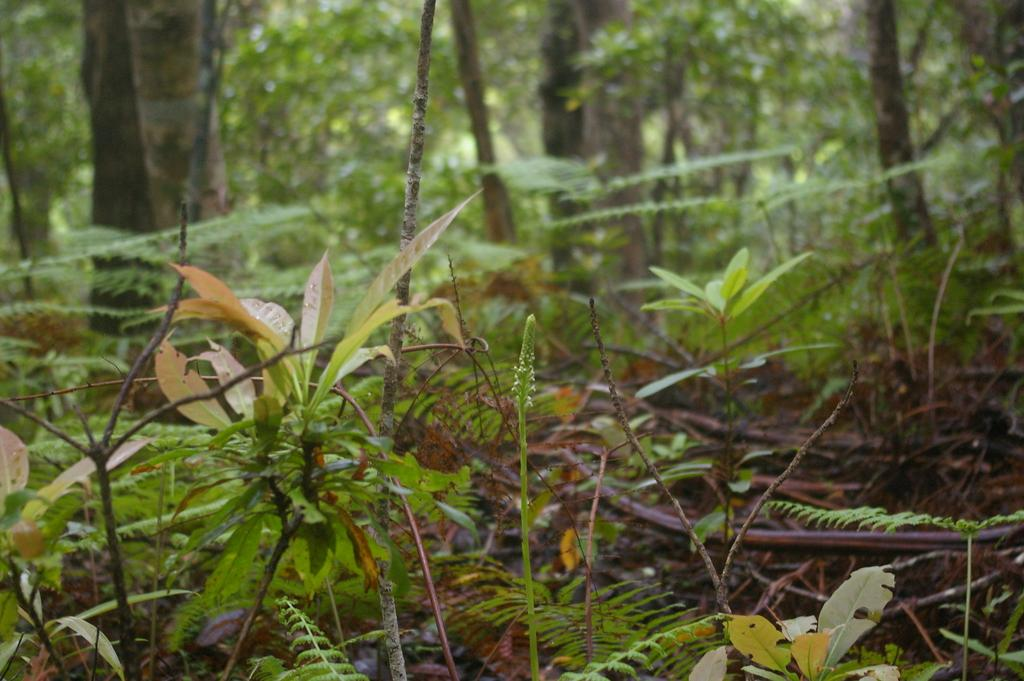What is located in the middle of the image? There are four plants in the middle of the image. What can be seen in the background of the image? There are tall trees with green leaves in the background. What type of objects are on the ground in the image? There are wooden sticks on the ground. What else is present on the ground in the image? Small leaves are present on the ground. How does the crowd affect the visibility of the plants in the image? There is no crowd present in the image, so it does not affect the visibility of the plants. What type of weather condition is depicted in the image due to the presence of fog? There is no fog present in the image, so it cannot be used to determine the weather condition. 